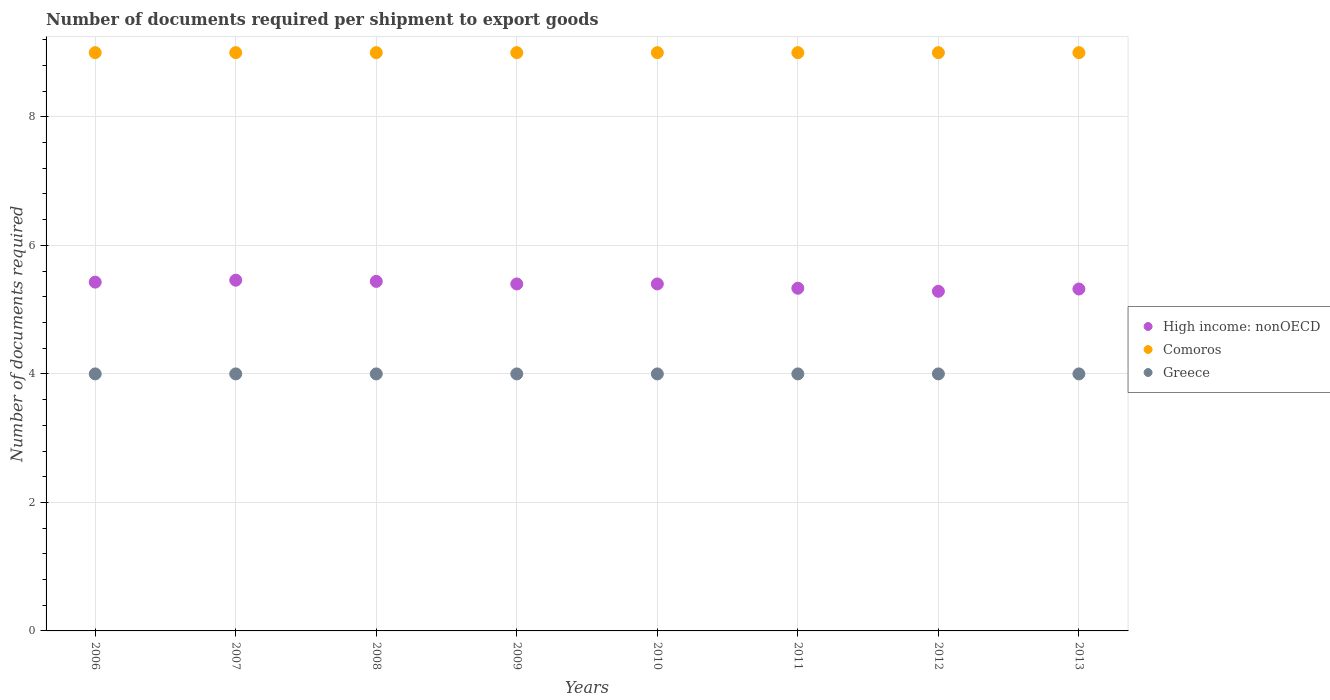Is the number of dotlines equal to the number of legend labels?
Give a very brief answer. Yes. What is the number of documents required per shipment to export goods in Greece in 2007?
Provide a short and direct response. 4. Across all years, what is the maximum number of documents required per shipment to export goods in Greece?
Provide a short and direct response. 4. Across all years, what is the minimum number of documents required per shipment to export goods in Greece?
Make the answer very short. 4. In which year was the number of documents required per shipment to export goods in High income: nonOECD maximum?
Provide a succinct answer. 2007. What is the total number of documents required per shipment to export goods in High income: nonOECD in the graph?
Offer a terse response. 43.07. What is the difference between the number of documents required per shipment to export goods in Comoros in 2008 and that in 2010?
Provide a succinct answer. 0. What is the difference between the number of documents required per shipment to export goods in Comoros in 2012 and the number of documents required per shipment to export goods in Greece in 2009?
Ensure brevity in your answer.  5. What is the average number of documents required per shipment to export goods in High income: nonOECD per year?
Keep it short and to the point. 5.38. In the year 2009, what is the difference between the number of documents required per shipment to export goods in Greece and number of documents required per shipment to export goods in High income: nonOECD?
Ensure brevity in your answer.  -1.4. Is the difference between the number of documents required per shipment to export goods in Greece in 2006 and 2008 greater than the difference between the number of documents required per shipment to export goods in High income: nonOECD in 2006 and 2008?
Your answer should be very brief. Yes. What is the difference between the highest and the second highest number of documents required per shipment to export goods in Comoros?
Keep it short and to the point. 0. What is the difference between the highest and the lowest number of documents required per shipment to export goods in High income: nonOECD?
Offer a very short reply. 0.17. Is it the case that in every year, the sum of the number of documents required per shipment to export goods in Comoros and number of documents required per shipment to export goods in Greece  is greater than the number of documents required per shipment to export goods in High income: nonOECD?
Offer a very short reply. Yes. How many dotlines are there?
Provide a succinct answer. 3. How many years are there in the graph?
Give a very brief answer. 8. Are the values on the major ticks of Y-axis written in scientific E-notation?
Your answer should be compact. No. Does the graph contain grids?
Offer a terse response. Yes. How many legend labels are there?
Provide a succinct answer. 3. What is the title of the graph?
Provide a succinct answer. Number of documents required per shipment to export goods. What is the label or title of the X-axis?
Give a very brief answer. Years. What is the label or title of the Y-axis?
Ensure brevity in your answer.  Number of documents required. What is the Number of documents required of High income: nonOECD in 2006?
Give a very brief answer. 5.43. What is the Number of documents required in Greece in 2006?
Your response must be concise. 4. What is the Number of documents required in High income: nonOECD in 2007?
Give a very brief answer. 5.46. What is the Number of documents required in Comoros in 2007?
Your response must be concise. 9. What is the Number of documents required of High income: nonOECD in 2008?
Make the answer very short. 5.44. What is the Number of documents required in High income: nonOECD in 2009?
Keep it short and to the point. 5.4. What is the Number of documents required of Greece in 2009?
Offer a very short reply. 4. What is the Number of documents required in High income: nonOECD in 2010?
Your answer should be compact. 5.4. What is the Number of documents required of Comoros in 2010?
Offer a very short reply. 9. What is the Number of documents required of Greece in 2010?
Your answer should be compact. 4. What is the Number of documents required in High income: nonOECD in 2011?
Your answer should be compact. 5.33. What is the Number of documents required in Comoros in 2011?
Keep it short and to the point. 9. What is the Number of documents required in Greece in 2011?
Give a very brief answer. 4. What is the Number of documents required in High income: nonOECD in 2012?
Your answer should be very brief. 5.29. What is the Number of documents required in Comoros in 2012?
Your answer should be very brief. 9. What is the Number of documents required of High income: nonOECD in 2013?
Your response must be concise. 5.32. Across all years, what is the maximum Number of documents required of High income: nonOECD?
Offer a very short reply. 5.46. Across all years, what is the maximum Number of documents required of Comoros?
Give a very brief answer. 9. Across all years, what is the minimum Number of documents required of High income: nonOECD?
Provide a succinct answer. 5.29. Across all years, what is the minimum Number of documents required of Comoros?
Ensure brevity in your answer.  9. Across all years, what is the minimum Number of documents required in Greece?
Provide a short and direct response. 4. What is the total Number of documents required in High income: nonOECD in the graph?
Give a very brief answer. 43.07. What is the total Number of documents required in Comoros in the graph?
Offer a very short reply. 72. What is the difference between the Number of documents required in High income: nonOECD in 2006 and that in 2007?
Your answer should be compact. -0.03. What is the difference between the Number of documents required in Comoros in 2006 and that in 2007?
Provide a succinct answer. 0. What is the difference between the Number of documents required of Greece in 2006 and that in 2007?
Provide a succinct answer. 0. What is the difference between the Number of documents required in High income: nonOECD in 2006 and that in 2008?
Provide a short and direct response. -0.01. What is the difference between the Number of documents required in High income: nonOECD in 2006 and that in 2009?
Keep it short and to the point. 0.03. What is the difference between the Number of documents required of Greece in 2006 and that in 2009?
Give a very brief answer. 0. What is the difference between the Number of documents required of High income: nonOECD in 2006 and that in 2010?
Your answer should be very brief. 0.03. What is the difference between the Number of documents required of Comoros in 2006 and that in 2010?
Ensure brevity in your answer.  0. What is the difference between the Number of documents required of Greece in 2006 and that in 2010?
Ensure brevity in your answer.  0. What is the difference between the Number of documents required in High income: nonOECD in 2006 and that in 2011?
Make the answer very short. 0.1. What is the difference between the Number of documents required of Greece in 2006 and that in 2011?
Provide a short and direct response. 0. What is the difference between the Number of documents required in High income: nonOECD in 2006 and that in 2012?
Keep it short and to the point. 0.14. What is the difference between the Number of documents required in High income: nonOECD in 2006 and that in 2013?
Offer a very short reply. 0.11. What is the difference between the Number of documents required in Comoros in 2006 and that in 2013?
Make the answer very short. 0. What is the difference between the Number of documents required of High income: nonOECD in 2007 and that in 2008?
Offer a terse response. 0.02. What is the difference between the Number of documents required of Greece in 2007 and that in 2008?
Your response must be concise. 0. What is the difference between the Number of documents required in High income: nonOECD in 2007 and that in 2009?
Ensure brevity in your answer.  0.06. What is the difference between the Number of documents required of Comoros in 2007 and that in 2009?
Provide a succinct answer. 0. What is the difference between the Number of documents required in Greece in 2007 and that in 2009?
Provide a succinct answer. 0. What is the difference between the Number of documents required of High income: nonOECD in 2007 and that in 2010?
Ensure brevity in your answer.  0.06. What is the difference between the Number of documents required of Comoros in 2007 and that in 2010?
Offer a terse response. 0. What is the difference between the Number of documents required of Greece in 2007 and that in 2010?
Your response must be concise. 0. What is the difference between the Number of documents required of Comoros in 2007 and that in 2011?
Give a very brief answer. 0. What is the difference between the Number of documents required of High income: nonOECD in 2007 and that in 2012?
Provide a succinct answer. 0.17. What is the difference between the Number of documents required of Greece in 2007 and that in 2012?
Offer a terse response. 0. What is the difference between the Number of documents required in High income: nonOECD in 2007 and that in 2013?
Your answer should be compact. 0.14. What is the difference between the Number of documents required in Comoros in 2007 and that in 2013?
Provide a short and direct response. 0. What is the difference between the Number of documents required in High income: nonOECD in 2008 and that in 2009?
Provide a succinct answer. 0.04. What is the difference between the Number of documents required in High income: nonOECD in 2008 and that in 2010?
Make the answer very short. 0.04. What is the difference between the Number of documents required in Greece in 2008 and that in 2010?
Ensure brevity in your answer.  0. What is the difference between the Number of documents required in High income: nonOECD in 2008 and that in 2011?
Provide a short and direct response. 0.11. What is the difference between the Number of documents required in Comoros in 2008 and that in 2011?
Keep it short and to the point. 0. What is the difference between the Number of documents required in High income: nonOECD in 2008 and that in 2012?
Provide a succinct answer. 0.15. What is the difference between the Number of documents required in High income: nonOECD in 2008 and that in 2013?
Your response must be concise. 0.12. What is the difference between the Number of documents required in Comoros in 2009 and that in 2010?
Give a very brief answer. 0. What is the difference between the Number of documents required in Greece in 2009 and that in 2010?
Make the answer very short. 0. What is the difference between the Number of documents required of High income: nonOECD in 2009 and that in 2011?
Your response must be concise. 0.07. What is the difference between the Number of documents required in Comoros in 2009 and that in 2011?
Provide a succinct answer. 0. What is the difference between the Number of documents required in Greece in 2009 and that in 2011?
Give a very brief answer. 0. What is the difference between the Number of documents required of High income: nonOECD in 2009 and that in 2012?
Your answer should be compact. 0.11. What is the difference between the Number of documents required of High income: nonOECD in 2009 and that in 2013?
Give a very brief answer. 0.08. What is the difference between the Number of documents required in Comoros in 2009 and that in 2013?
Provide a short and direct response. 0. What is the difference between the Number of documents required in Greece in 2009 and that in 2013?
Offer a very short reply. 0. What is the difference between the Number of documents required in High income: nonOECD in 2010 and that in 2011?
Your answer should be very brief. 0.07. What is the difference between the Number of documents required of Greece in 2010 and that in 2011?
Give a very brief answer. 0. What is the difference between the Number of documents required of High income: nonOECD in 2010 and that in 2012?
Provide a succinct answer. 0.11. What is the difference between the Number of documents required in Comoros in 2010 and that in 2012?
Your answer should be very brief. 0. What is the difference between the Number of documents required of Greece in 2010 and that in 2012?
Make the answer very short. 0. What is the difference between the Number of documents required in High income: nonOECD in 2010 and that in 2013?
Make the answer very short. 0.08. What is the difference between the Number of documents required of Comoros in 2010 and that in 2013?
Your answer should be very brief. 0. What is the difference between the Number of documents required of High income: nonOECD in 2011 and that in 2012?
Keep it short and to the point. 0.05. What is the difference between the Number of documents required in High income: nonOECD in 2011 and that in 2013?
Provide a short and direct response. 0.01. What is the difference between the Number of documents required in High income: nonOECD in 2012 and that in 2013?
Provide a succinct answer. -0.04. What is the difference between the Number of documents required in Greece in 2012 and that in 2013?
Your answer should be very brief. 0. What is the difference between the Number of documents required of High income: nonOECD in 2006 and the Number of documents required of Comoros in 2007?
Your answer should be compact. -3.57. What is the difference between the Number of documents required in High income: nonOECD in 2006 and the Number of documents required in Greece in 2007?
Give a very brief answer. 1.43. What is the difference between the Number of documents required of High income: nonOECD in 2006 and the Number of documents required of Comoros in 2008?
Offer a terse response. -3.57. What is the difference between the Number of documents required of High income: nonOECD in 2006 and the Number of documents required of Greece in 2008?
Provide a succinct answer. 1.43. What is the difference between the Number of documents required in Comoros in 2006 and the Number of documents required in Greece in 2008?
Provide a succinct answer. 5. What is the difference between the Number of documents required of High income: nonOECD in 2006 and the Number of documents required of Comoros in 2009?
Keep it short and to the point. -3.57. What is the difference between the Number of documents required of High income: nonOECD in 2006 and the Number of documents required of Greece in 2009?
Provide a short and direct response. 1.43. What is the difference between the Number of documents required of High income: nonOECD in 2006 and the Number of documents required of Comoros in 2010?
Offer a very short reply. -3.57. What is the difference between the Number of documents required of High income: nonOECD in 2006 and the Number of documents required of Greece in 2010?
Your answer should be very brief. 1.43. What is the difference between the Number of documents required in High income: nonOECD in 2006 and the Number of documents required in Comoros in 2011?
Your answer should be very brief. -3.57. What is the difference between the Number of documents required in High income: nonOECD in 2006 and the Number of documents required in Greece in 2011?
Offer a terse response. 1.43. What is the difference between the Number of documents required in High income: nonOECD in 2006 and the Number of documents required in Comoros in 2012?
Offer a terse response. -3.57. What is the difference between the Number of documents required in High income: nonOECD in 2006 and the Number of documents required in Greece in 2012?
Make the answer very short. 1.43. What is the difference between the Number of documents required in Comoros in 2006 and the Number of documents required in Greece in 2012?
Ensure brevity in your answer.  5. What is the difference between the Number of documents required in High income: nonOECD in 2006 and the Number of documents required in Comoros in 2013?
Your answer should be compact. -3.57. What is the difference between the Number of documents required in High income: nonOECD in 2006 and the Number of documents required in Greece in 2013?
Your answer should be very brief. 1.43. What is the difference between the Number of documents required in Comoros in 2006 and the Number of documents required in Greece in 2013?
Give a very brief answer. 5. What is the difference between the Number of documents required of High income: nonOECD in 2007 and the Number of documents required of Comoros in 2008?
Your response must be concise. -3.54. What is the difference between the Number of documents required of High income: nonOECD in 2007 and the Number of documents required of Greece in 2008?
Keep it short and to the point. 1.46. What is the difference between the Number of documents required of Comoros in 2007 and the Number of documents required of Greece in 2008?
Give a very brief answer. 5. What is the difference between the Number of documents required in High income: nonOECD in 2007 and the Number of documents required in Comoros in 2009?
Your answer should be very brief. -3.54. What is the difference between the Number of documents required in High income: nonOECD in 2007 and the Number of documents required in Greece in 2009?
Ensure brevity in your answer.  1.46. What is the difference between the Number of documents required in Comoros in 2007 and the Number of documents required in Greece in 2009?
Provide a short and direct response. 5. What is the difference between the Number of documents required of High income: nonOECD in 2007 and the Number of documents required of Comoros in 2010?
Your answer should be compact. -3.54. What is the difference between the Number of documents required of High income: nonOECD in 2007 and the Number of documents required of Greece in 2010?
Provide a succinct answer. 1.46. What is the difference between the Number of documents required of Comoros in 2007 and the Number of documents required of Greece in 2010?
Ensure brevity in your answer.  5. What is the difference between the Number of documents required in High income: nonOECD in 2007 and the Number of documents required in Comoros in 2011?
Provide a short and direct response. -3.54. What is the difference between the Number of documents required in High income: nonOECD in 2007 and the Number of documents required in Greece in 2011?
Ensure brevity in your answer.  1.46. What is the difference between the Number of documents required in High income: nonOECD in 2007 and the Number of documents required in Comoros in 2012?
Offer a terse response. -3.54. What is the difference between the Number of documents required of High income: nonOECD in 2007 and the Number of documents required of Greece in 2012?
Offer a terse response. 1.46. What is the difference between the Number of documents required in Comoros in 2007 and the Number of documents required in Greece in 2012?
Make the answer very short. 5. What is the difference between the Number of documents required of High income: nonOECD in 2007 and the Number of documents required of Comoros in 2013?
Your response must be concise. -3.54. What is the difference between the Number of documents required of High income: nonOECD in 2007 and the Number of documents required of Greece in 2013?
Your answer should be very brief. 1.46. What is the difference between the Number of documents required in High income: nonOECD in 2008 and the Number of documents required in Comoros in 2009?
Your response must be concise. -3.56. What is the difference between the Number of documents required in High income: nonOECD in 2008 and the Number of documents required in Greece in 2009?
Give a very brief answer. 1.44. What is the difference between the Number of documents required in High income: nonOECD in 2008 and the Number of documents required in Comoros in 2010?
Offer a terse response. -3.56. What is the difference between the Number of documents required of High income: nonOECD in 2008 and the Number of documents required of Greece in 2010?
Your answer should be compact. 1.44. What is the difference between the Number of documents required of Comoros in 2008 and the Number of documents required of Greece in 2010?
Offer a terse response. 5. What is the difference between the Number of documents required of High income: nonOECD in 2008 and the Number of documents required of Comoros in 2011?
Make the answer very short. -3.56. What is the difference between the Number of documents required in High income: nonOECD in 2008 and the Number of documents required in Greece in 2011?
Your answer should be very brief. 1.44. What is the difference between the Number of documents required of Comoros in 2008 and the Number of documents required of Greece in 2011?
Make the answer very short. 5. What is the difference between the Number of documents required in High income: nonOECD in 2008 and the Number of documents required in Comoros in 2012?
Offer a very short reply. -3.56. What is the difference between the Number of documents required in High income: nonOECD in 2008 and the Number of documents required in Greece in 2012?
Your answer should be very brief. 1.44. What is the difference between the Number of documents required in High income: nonOECD in 2008 and the Number of documents required in Comoros in 2013?
Your response must be concise. -3.56. What is the difference between the Number of documents required in High income: nonOECD in 2008 and the Number of documents required in Greece in 2013?
Provide a short and direct response. 1.44. What is the difference between the Number of documents required in Comoros in 2008 and the Number of documents required in Greece in 2013?
Give a very brief answer. 5. What is the difference between the Number of documents required in High income: nonOECD in 2009 and the Number of documents required in Greece in 2010?
Provide a short and direct response. 1.4. What is the difference between the Number of documents required in High income: nonOECD in 2009 and the Number of documents required in Comoros in 2011?
Give a very brief answer. -3.6. What is the difference between the Number of documents required in High income: nonOECD in 2009 and the Number of documents required in Greece in 2011?
Give a very brief answer. 1.4. What is the difference between the Number of documents required in Comoros in 2009 and the Number of documents required in Greece in 2011?
Give a very brief answer. 5. What is the difference between the Number of documents required of Comoros in 2009 and the Number of documents required of Greece in 2012?
Offer a terse response. 5. What is the difference between the Number of documents required of High income: nonOECD in 2009 and the Number of documents required of Greece in 2013?
Give a very brief answer. 1.4. What is the difference between the Number of documents required in High income: nonOECD in 2010 and the Number of documents required in Comoros in 2011?
Ensure brevity in your answer.  -3.6. What is the difference between the Number of documents required of High income: nonOECD in 2010 and the Number of documents required of Greece in 2011?
Offer a very short reply. 1.4. What is the difference between the Number of documents required in High income: nonOECD in 2010 and the Number of documents required in Comoros in 2012?
Provide a succinct answer. -3.6. What is the difference between the Number of documents required of High income: nonOECD in 2010 and the Number of documents required of Comoros in 2013?
Offer a very short reply. -3.6. What is the difference between the Number of documents required of High income: nonOECD in 2011 and the Number of documents required of Comoros in 2012?
Provide a short and direct response. -3.67. What is the difference between the Number of documents required of High income: nonOECD in 2011 and the Number of documents required of Comoros in 2013?
Your response must be concise. -3.67. What is the difference between the Number of documents required of High income: nonOECD in 2011 and the Number of documents required of Greece in 2013?
Give a very brief answer. 1.33. What is the difference between the Number of documents required in Comoros in 2011 and the Number of documents required in Greece in 2013?
Your answer should be compact. 5. What is the difference between the Number of documents required of High income: nonOECD in 2012 and the Number of documents required of Comoros in 2013?
Offer a very short reply. -3.71. What is the average Number of documents required of High income: nonOECD per year?
Provide a succinct answer. 5.38. What is the average Number of documents required of Comoros per year?
Your answer should be compact. 9. In the year 2006, what is the difference between the Number of documents required in High income: nonOECD and Number of documents required in Comoros?
Your response must be concise. -3.57. In the year 2006, what is the difference between the Number of documents required of High income: nonOECD and Number of documents required of Greece?
Your response must be concise. 1.43. In the year 2007, what is the difference between the Number of documents required of High income: nonOECD and Number of documents required of Comoros?
Offer a terse response. -3.54. In the year 2007, what is the difference between the Number of documents required of High income: nonOECD and Number of documents required of Greece?
Provide a short and direct response. 1.46. In the year 2008, what is the difference between the Number of documents required of High income: nonOECD and Number of documents required of Comoros?
Your response must be concise. -3.56. In the year 2008, what is the difference between the Number of documents required in High income: nonOECD and Number of documents required in Greece?
Offer a very short reply. 1.44. In the year 2009, what is the difference between the Number of documents required of Comoros and Number of documents required of Greece?
Provide a succinct answer. 5. In the year 2010, what is the difference between the Number of documents required in High income: nonOECD and Number of documents required in Greece?
Your response must be concise. 1.4. In the year 2011, what is the difference between the Number of documents required of High income: nonOECD and Number of documents required of Comoros?
Your answer should be very brief. -3.67. In the year 2011, what is the difference between the Number of documents required in Comoros and Number of documents required in Greece?
Make the answer very short. 5. In the year 2012, what is the difference between the Number of documents required in High income: nonOECD and Number of documents required in Comoros?
Offer a very short reply. -3.71. In the year 2013, what is the difference between the Number of documents required in High income: nonOECD and Number of documents required in Comoros?
Ensure brevity in your answer.  -3.68. In the year 2013, what is the difference between the Number of documents required of High income: nonOECD and Number of documents required of Greece?
Make the answer very short. 1.32. In the year 2013, what is the difference between the Number of documents required in Comoros and Number of documents required in Greece?
Offer a very short reply. 5. What is the ratio of the Number of documents required of Greece in 2006 to that in 2007?
Your answer should be compact. 1. What is the ratio of the Number of documents required of Comoros in 2006 to that in 2008?
Offer a very short reply. 1. What is the ratio of the Number of documents required of Greece in 2006 to that in 2008?
Make the answer very short. 1. What is the ratio of the Number of documents required in High income: nonOECD in 2006 to that in 2009?
Keep it short and to the point. 1.01. What is the ratio of the Number of documents required of Comoros in 2006 to that in 2009?
Offer a terse response. 1. What is the ratio of the Number of documents required in High income: nonOECD in 2006 to that in 2010?
Provide a succinct answer. 1.01. What is the ratio of the Number of documents required in Comoros in 2006 to that in 2010?
Keep it short and to the point. 1. What is the ratio of the Number of documents required in Greece in 2006 to that in 2010?
Offer a very short reply. 1. What is the ratio of the Number of documents required in High income: nonOECD in 2006 to that in 2011?
Your answer should be compact. 1.02. What is the ratio of the Number of documents required in High income: nonOECD in 2006 to that in 2012?
Provide a short and direct response. 1.03. What is the ratio of the Number of documents required of Comoros in 2006 to that in 2012?
Your answer should be compact. 1. What is the ratio of the Number of documents required of High income: nonOECD in 2006 to that in 2013?
Keep it short and to the point. 1.02. What is the ratio of the Number of documents required in Comoros in 2006 to that in 2013?
Offer a very short reply. 1. What is the ratio of the Number of documents required of Greece in 2006 to that in 2013?
Offer a terse response. 1. What is the ratio of the Number of documents required of High income: nonOECD in 2007 to that in 2008?
Your answer should be very brief. 1. What is the ratio of the Number of documents required of Comoros in 2007 to that in 2008?
Your response must be concise. 1. What is the ratio of the Number of documents required of Greece in 2007 to that in 2008?
Ensure brevity in your answer.  1. What is the ratio of the Number of documents required of High income: nonOECD in 2007 to that in 2009?
Keep it short and to the point. 1.01. What is the ratio of the Number of documents required in Comoros in 2007 to that in 2009?
Your answer should be very brief. 1. What is the ratio of the Number of documents required of Greece in 2007 to that in 2009?
Your answer should be compact. 1. What is the ratio of the Number of documents required in High income: nonOECD in 2007 to that in 2010?
Give a very brief answer. 1.01. What is the ratio of the Number of documents required of Comoros in 2007 to that in 2010?
Ensure brevity in your answer.  1. What is the ratio of the Number of documents required in High income: nonOECD in 2007 to that in 2011?
Provide a succinct answer. 1.02. What is the ratio of the Number of documents required of High income: nonOECD in 2007 to that in 2012?
Provide a succinct answer. 1.03. What is the ratio of the Number of documents required in Greece in 2007 to that in 2012?
Provide a succinct answer. 1. What is the ratio of the Number of documents required of High income: nonOECD in 2007 to that in 2013?
Give a very brief answer. 1.03. What is the ratio of the Number of documents required of Comoros in 2007 to that in 2013?
Your answer should be compact. 1. What is the ratio of the Number of documents required of High income: nonOECD in 2008 to that in 2009?
Your answer should be very brief. 1.01. What is the ratio of the Number of documents required of High income: nonOECD in 2008 to that in 2010?
Give a very brief answer. 1.01. What is the ratio of the Number of documents required in Comoros in 2008 to that in 2010?
Your response must be concise. 1. What is the ratio of the Number of documents required in Comoros in 2008 to that in 2011?
Your response must be concise. 1. What is the ratio of the Number of documents required in Greece in 2008 to that in 2011?
Ensure brevity in your answer.  1. What is the ratio of the Number of documents required of High income: nonOECD in 2008 to that in 2012?
Keep it short and to the point. 1.03. What is the ratio of the Number of documents required in Comoros in 2008 to that in 2012?
Offer a terse response. 1. What is the ratio of the Number of documents required in High income: nonOECD in 2008 to that in 2013?
Your answer should be very brief. 1.02. What is the ratio of the Number of documents required of Comoros in 2008 to that in 2013?
Provide a short and direct response. 1. What is the ratio of the Number of documents required of High income: nonOECD in 2009 to that in 2011?
Give a very brief answer. 1.01. What is the ratio of the Number of documents required in High income: nonOECD in 2009 to that in 2012?
Offer a terse response. 1.02. What is the ratio of the Number of documents required of Comoros in 2009 to that in 2012?
Offer a very short reply. 1. What is the ratio of the Number of documents required of High income: nonOECD in 2009 to that in 2013?
Keep it short and to the point. 1.01. What is the ratio of the Number of documents required of Comoros in 2009 to that in 2013?
Ensure brevity in your answer.  1. What is the ratio of the Number of documents required of High income: nonOECD in 2010 to that in 2011?
Your response must be concise. 1.01. What is the ratio of the Number of documents required in Greece in 2010 to that in 2011?
Provide a succinct answer. 1. What is the ratio of the Number of documents required of High income: nonOECD in 2010 to that in 2012?
Your response must be concise. 1.02. What is the ratio of the Number of documents required in Comoros in 2010 to that in 2012?
Offer a very short reply. 1. What is the ratio of the Number of documents required in High income: nonOECD in 2010 to that in 2013?
Provide a succinct answer. 1.01. What is the ratio of the Number of documents required in Greece in 2010 to that in 2013?
Your answer should be very brief. 1. What is the ratio of the Number of documents required in Greece in 2011 to that in 2012?
Make the answer very short. 1. What is the ratio of the Number of documents required of Comoros in 2011 to that in 2013?
Your answer should be compact. 1. What is the ratio of the Number of documents required of High income: nonOECD in 2012 to that in 2013?
Offer a very short reply. 0.99. What is the ratio of the Number of documents required of Comoros in 2012 to that in 2013?
Keep it short and to the point. 1. What is the difference between the highest and the second highest Number of documents required of High income: nonOECD?
Your answer should be very brief. 0.02. What is the difference between the highest and the second highest Number of documents required of Greece?
Ensure brevity in your answer.  0. What is the difference between the highest and the lowest Number of documents required of High income: nonOECD?
Offer a terse response. 0.17. 